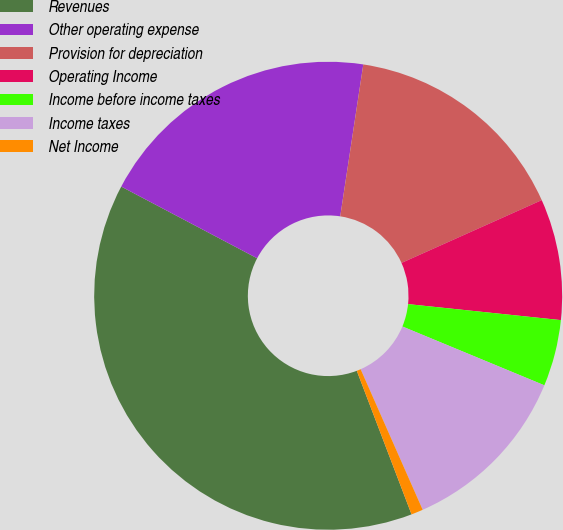Convert chart. <chart><loc_0><loc_0><loc_500><loc_500><pie_chart><fcel>Revenues<fcel>Other operating expense<fcel>Provision for depreciation<fcel>Operating Income<fcel>Income before income taxes<fcel>Income taxes<fcel>Net Income<nl><fcel>38.52%<fcel>19.67%<fcel>15.9%<fcel>8.36%<fcel>4.59%<fcel>12.13%<fcel>0.82%<nl></chart> 